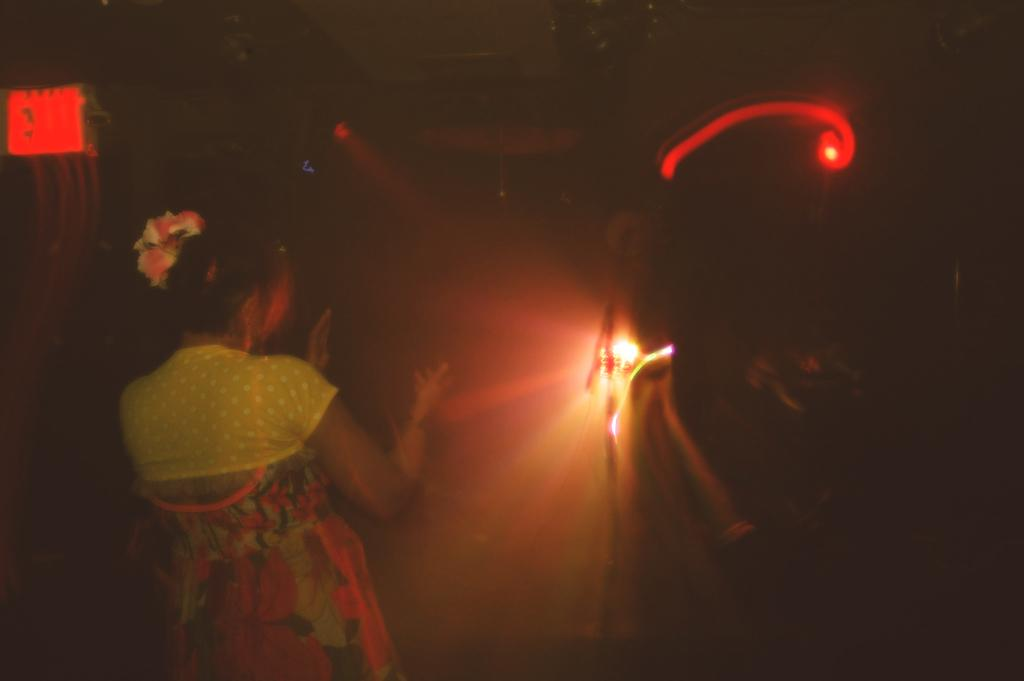What is the overall appearance of the image? The image has a dark appearance. Can you describe the person in the image? There is a woman standing in the image. What can be seen in addition to the woman? There are lights visible in the image. What type of basketball game is taking place in the image? There is no basketball game present in the image. Can you describe the heart-shaped object in the image? There is no heart-shaped object present in the image. 